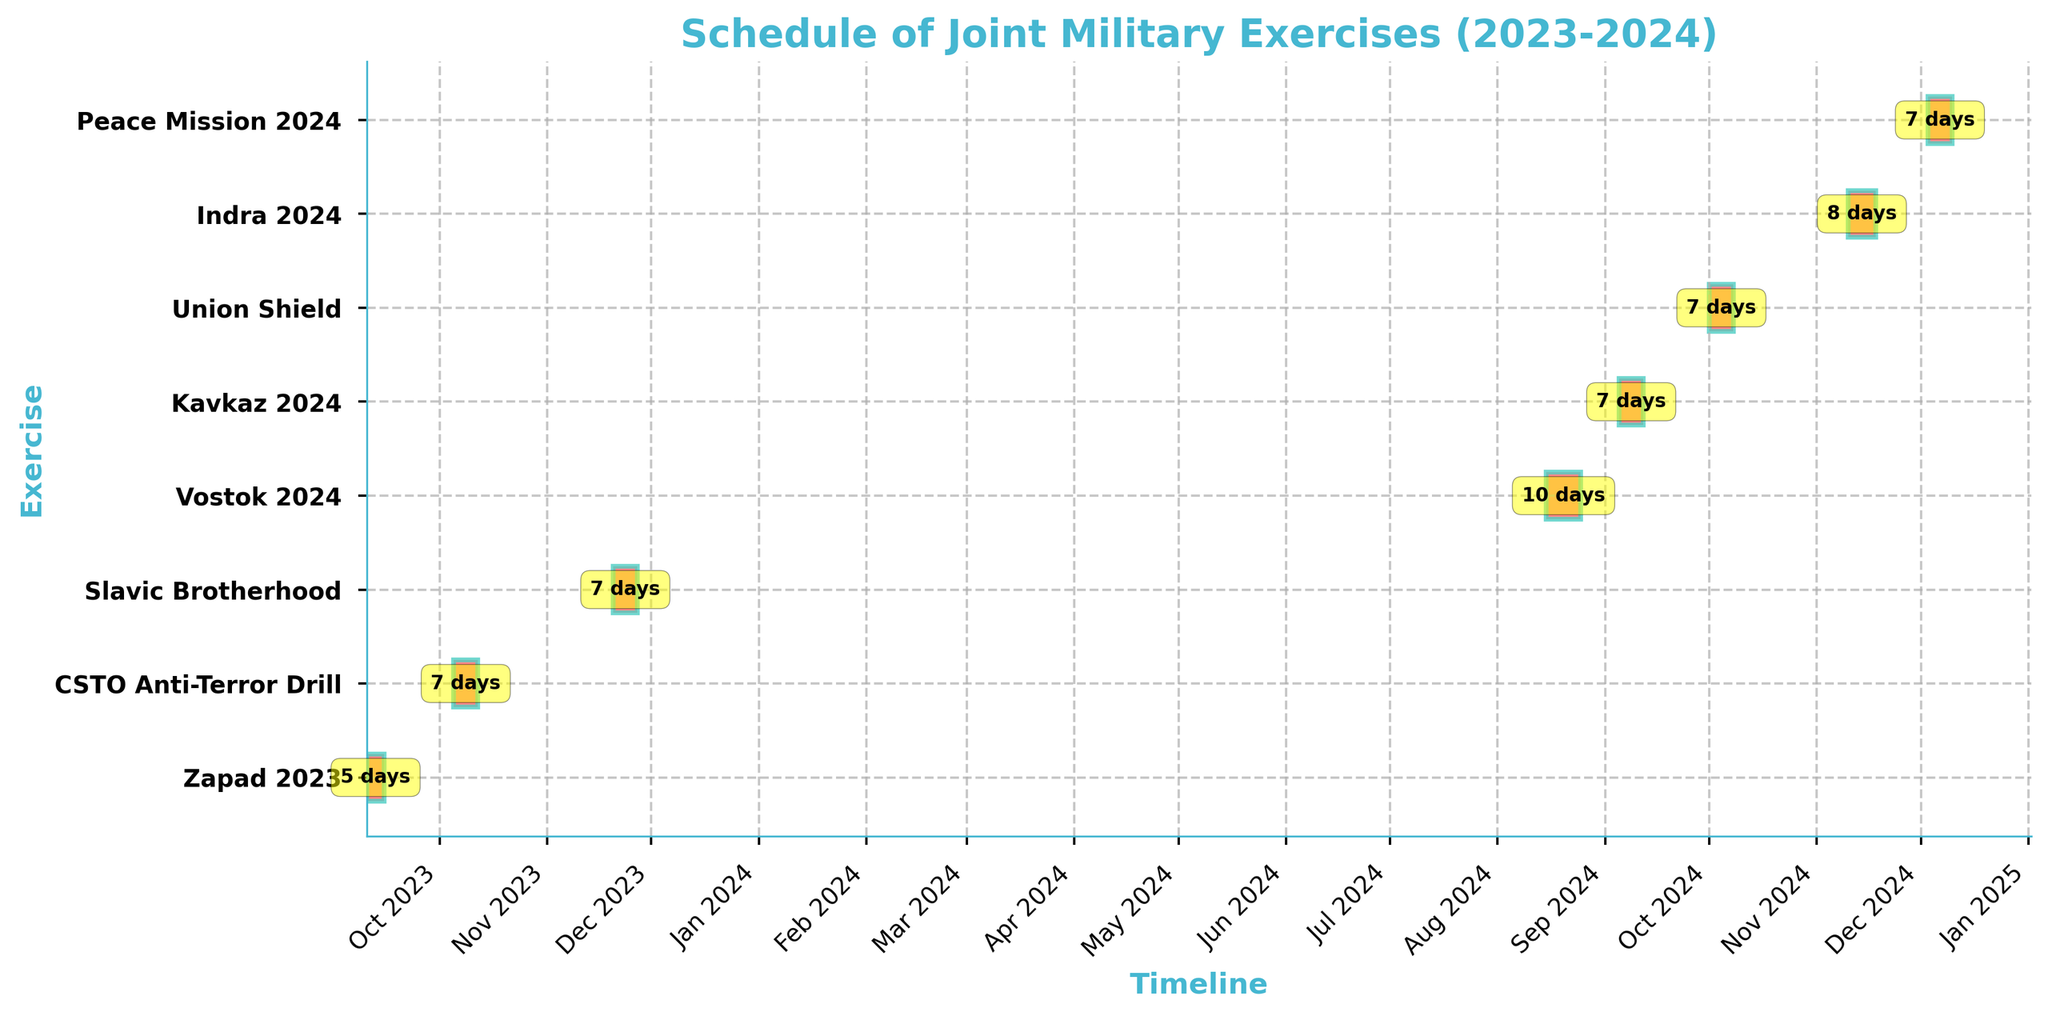What's the title of the figure? The title is prominently displayed at the top of the chart. It summarizes the information presented in the figure.
Answer: Schedule of Joint Military Exercises (2023-2024) During which month of 2023 did the first exercise occur? The first bar on the chart corresponds to the earliest start date, which falls in September 2023.
Answer: September How many days does the "Zapad 2023" exercise last? The duration of the exercise is annotated above the respective bar, showing the number of days between the start and end dates.
Answer: 5 days Which exercise spans over the longest period, and how long is it? By comparing the lengths of all the bars visually, the "Vostok 2024" exercise has the longest bar, which lasts from August 15 to August 25.
Answer: Vostok 2024, 10 days How many exercises are scheduled to occur in October 2024? Inspect the x-axis for October 2024 and count the bars that start or end within this month. The "Union Shield" exercise is scheduled.
Answer: 1 exercise Which exercises last exactly a week? Look for bars with annotations indicating a duration of 7 days under the respective bars.
Answer: CSTO Anti-Terror Drill, Kavkaz 2024, Peace Mission 2024 Between which months of 2024 do the maximum number of exercises take place? Examine the x-axis for 2024 and identify the months with the most bars starting or ending within those months. November and December see the most exercises.
Answer: November to December What is the total duration of all exercises combined in 2024? Sum durations of all exercises in 2024: Vostok 2024 (10), Kavkaz 2024 (7), Union Shield (7), Indra 2024 (8), Peace Mission 2024 (7): 10+7+7+8+7.
Answer: 39 days Which exercise has the shortest duration, and what is it? Identify the shortest bar and check its annotation for the duration. The "Zapad 2023" exercise is the shortest.
Answer: Zapad 2023, 5 days Are there more exercises scheduled in 2023 or in 2024? Count the number of exercises' bars falling under 2023 and 2024 respectively. 2023 has 3 exercises and 2024 has 5 exercises.
Answer: More in 2024 